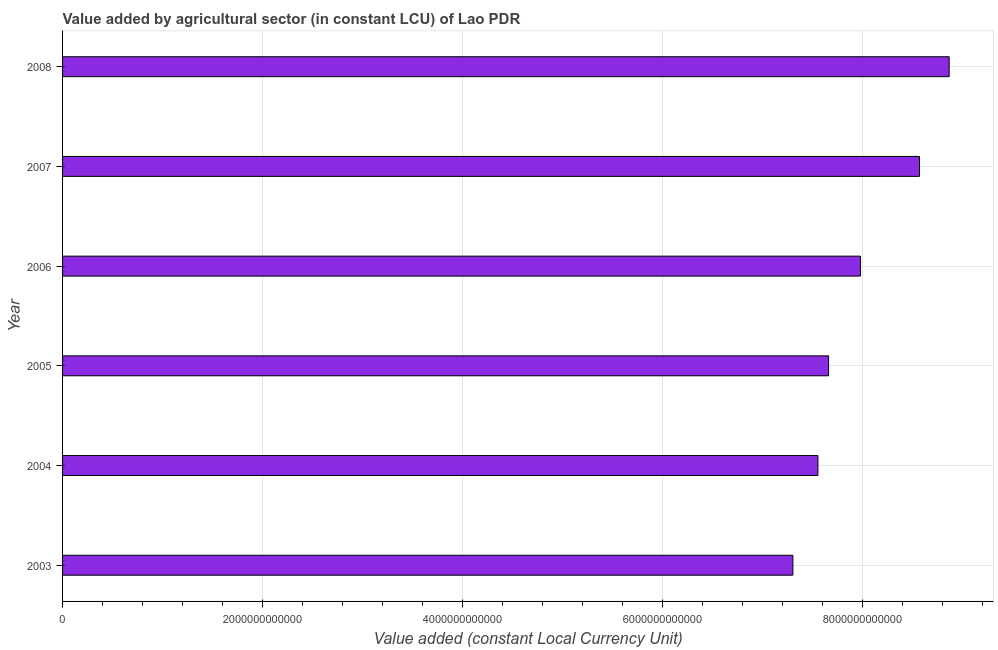Does the graph contain any zero values?
Offer a terse response. No. Does the graph contain grids?
Offer a terse response. Yes. What is the title of the graph?
Keep it short and to the point. Value added by agricultural sector (in constant LCU) of Lao PDR. What is the label or title of the X-axis?
Your answer should be very brief. Value added (constant Local Currency Unit). What is the value added by agriculture sector in 2008?
Your answer should be very brief. 8.87e+12. Across all years, what is the maximum value added by agriculture sector?
Make the answer very short. 8.87e+12. Across all years, what is the minimum value added by agriculture sector?
Keep it short and to the point. 7.30e+12. In which year was the value added by agriculture sector maximum?
Ensure brevity in your answer.  2008. What is the sum of the value added by agriculture sector?
Provide a succinct answer. 4.79e+13. What is the difference between the value added by agriculture sector in 2003 and 2004?
Give a very brief answer. -2.50e+11. What is the average value added by agriculture sector per year?
Give a very brief answer. 7.99e+12. What is the median value added by agriculture sector?
Your response must be concise. 7.82e+12. In how many years, is the value added by agriculture sector greater than 2000000000000 LCU?
Your response must be concise. 6. Do a majority of the years between 2003 and 2006 (inclusive) have value added by agriculture sector greater than 7200000000000 LCU?
Provide a short and direct response. Yes. What is the ratio of the value added by agriculture sector in 2003 to that in 2007?
Give a very brief answer. 0.85. Is the difference between the value added by agriculture sector in 2004 and 2005 greater than the difference between any two years?
Provide a succinct answer. No. What is the difference between the highest and the second highest value added by agriculture sector?
Offer a terse response. 2.96e+11. Is the sum of the value added by agriculture sector in 2003 and 2007 greater than the maximum value added by agriculture sector across all years?
Offer a terse response. Yes. What is the difference between the highest and the lowest value added by agriculture sector?
Keep it short and to the point. 1.56e+12. How many bars are there?
Provide a succinct answer. 6. How many years are there in the graph?
Provide a succinct answer. 6. What is the difference between two consecutive major ticks on the X-axis?
Give a very brief answer. 2.00e+12. What is the Value added (constant Local Currency Unit) in 2003?
Provide a short and direct response. 7.30e+12. What is the Value added (constant Local Currency Unit) of 2004?
Provide a succinct answer. 7.55e+12. What is the Value added (constant Local Currency Unit) in 2005?
Your answer should be compact. 7.66e+12. What is the Value added (constant Local Currency Unit) in 2006?
Provide a short and direct response. 7.98e+12. What is the Value added (constant Local Currency Unit) in 2007?
Keep it short and to the point. 8.57e+12. What is the Value added (constant Local Currency Unit) in 2008?
Offer a terse response. 8.87e+12. What is the difference between the Value added (constant Local Currency Unit) in 2003 and 2004?
Your response must be concise. -2.50e+11. What is the difference between the Value added (constant Local Currency Unit) in 2003 and 2005?
Provide a succinct answer. -3.57e+11. What is the difference between the Value added (constant Local Currency Unit) in 2003 and 2006?
Provide a short and direct response. -6.75e+11. What is the difference between the Value added (constant Local Currency Unit) in 2003 and 2007?
Provide a short and direct response. -1.27e+12. What is the difference between the Value added (constant Local Currency Unit) in 2003 and 2008?
Provide a short and direct response. -1.56e+12. What is the difference between the Value added (constant Local Currency Unit) in 2004 and 2005?
Your answer should be very brief. -1.07e+11. What is the difference between the Value added (constant Local Currency Unit) in 2004 and 2006?
Give a very brief answer. -4.25e+11. What is the difference between the Value added (constant Local Currency Unit) in 2004 and 2007?
Offer a terse response. -1.02e+12. What is the difference between the Value added (constant Local Currency Unit) in 2004 and 2008?
Keep it short and to the point. -1.31e+12. What is the difference between the Value added (constant Local Currency Unit) in 2005 and 2006?
Your answer should be very brief. -3.18e+11. What is the difference between the Value added (constant Local Currency Unit) in 2005 and 2007?
Ensure brevity in your answer.  -9.09e+11. What is the difference between the Value added (constant Local Currency Unit) in 2005 and 2008?
Ensure brevity in your answer.  -1.21e+12. What is the difference between the Value added (constant Local Currency Unit) in 2006 and 2007?
Make the answer very short. -5.91e+11. What is the difference between the Value added (constant Local Currency Unit) in 2006 and 2008?
Your answer should be very brief. -8.87e+11. What is the difference between the Value added (constant Local Currency Unit) in 2007 and 2008?
Your answer should be compact. -2.96e+11. What is the ratio of the Value added (constant Local Currency Unit) in 2003 to that in 2004?
Your answer should be compact. 0.97. What is the ratio of the Value added (constant Local Currency Unit) in 2003 to that in 2005?
Offer a terse response. 0.95. What is the ratio of the Value added (constant Local Currency Unit) in 2003 to that in 2006?
Give a very brief answer. 0.92. What is the ratio of the Value added (constant Local Currency Unit) in 2003 to that in 2007?
Provide a short and direct response. 0.85. What is the ratio of the Value added (constant Local Currency Unit) in 2003 to that in 2008?
Make the answer very short. 0.82. What is the ratio of the Value added (constant Local Currency Unit) in 2004 to that in 2005?
Give a very brief answer. 0.99. What is the ratio of the Value added (constant Local Currency Unit) in 2004 to that in 2006?
Offer a very short reply. 0.95. What is the ratio of the Value added (constant Local Currency Unit) in 2004 to that in 2007?
Your response must be concise. 0.88. What is the ratio of the Value added (constant Local Currency Unit) in 2004 to that in 2008?
Offer a very short reply. 0.85. What is the ratio of the Value added (constant Local Currency Unit) in 2005 to that in 2007?
Your answer should be very brief. 0.89. What is the ratio of the Value added (constant Local Currency Unit) in 2005 to that in 2008?
Your answer should be compact. 0.86. 